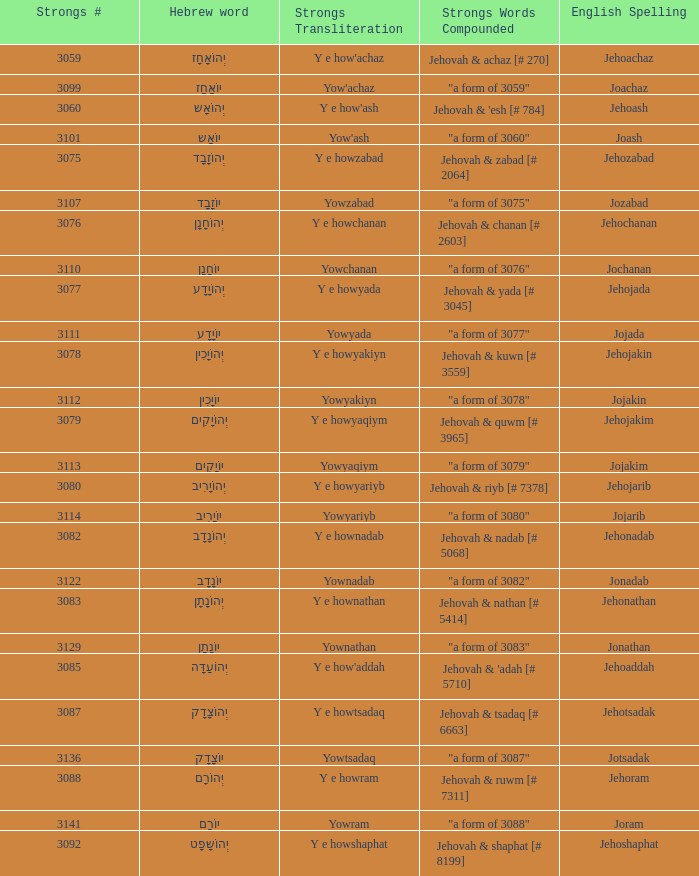What is the potent transliteration of the hebrew word יוֹחָנָן? Yowchanan. 